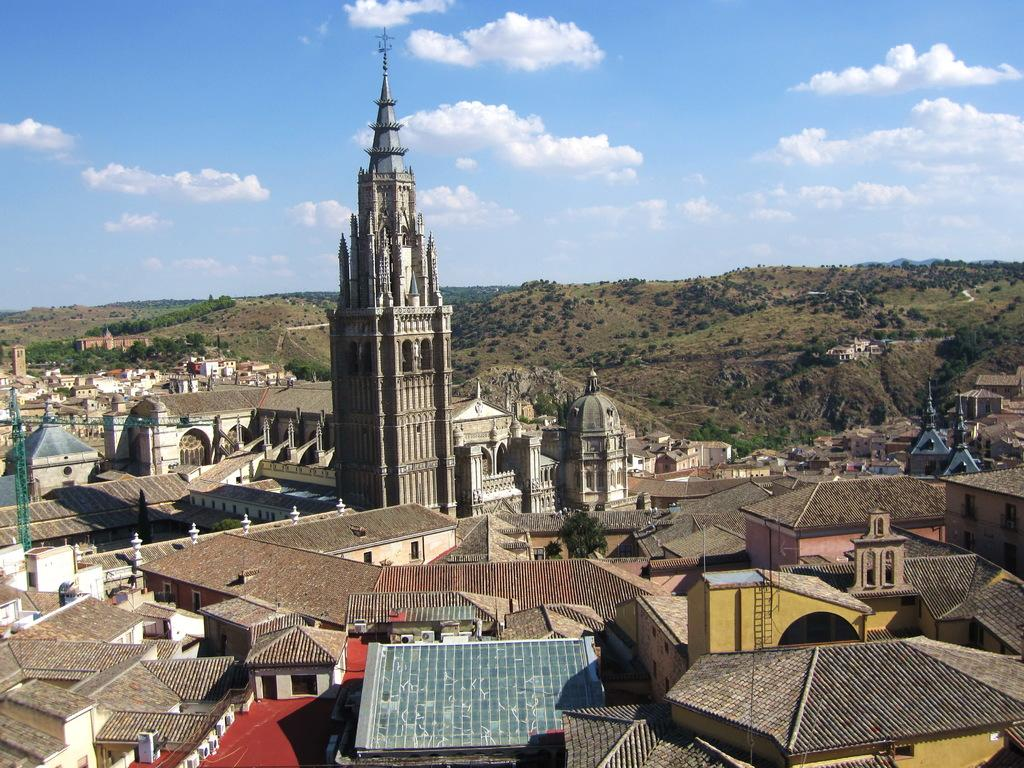What type of structures can be seen in the image? There are buildings in the image. What feature is visible on the buildings? There are windows visible in the image. What type of natural elements are present in the image? There are trees in the image. What is the color of the sky in the image? The sky is blue and white in color. How much money is being exchanged in the image? There is no indication of money being exchanged in the image. What type of shop can be seen in the image? There is no shop present in the image. 